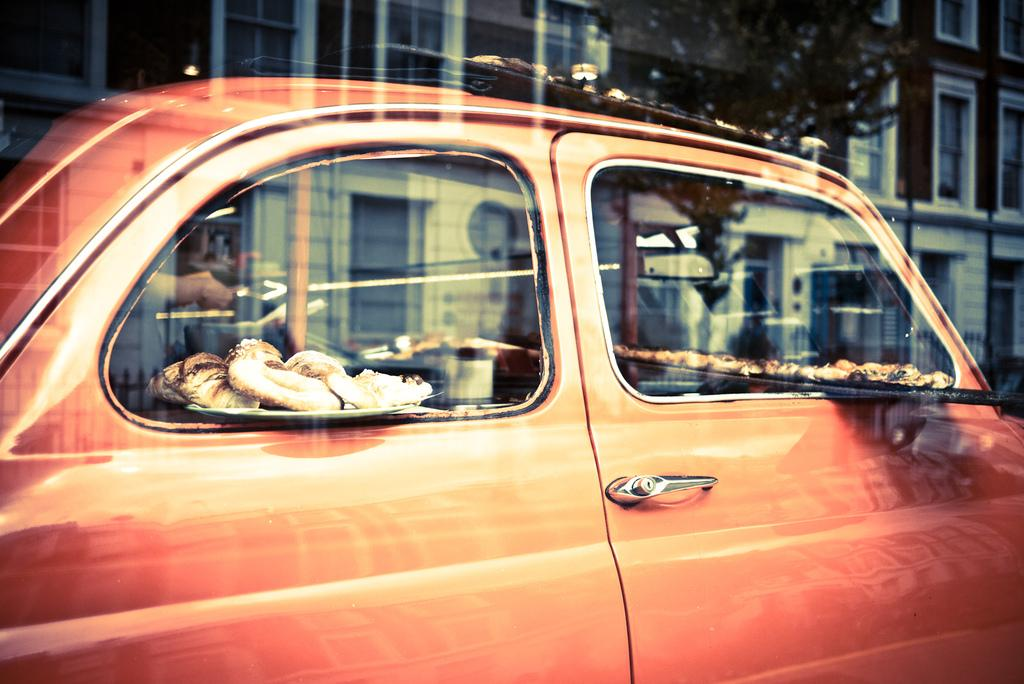What color is the car in the image? The car in the image is orange. What is on the plate can be seen in the image? There is a plate containing eatables in the image. Whose hands are visible in the image? The hands of a person are visible in the image. What can be seen in the distance in the image? There are buildings and a tree in the background of the image. Can you tell me what time the person is wearing on their wrist in the image? There is no watch visible on the person's wrist in the image. What type of sea creature can be seen swimming in the background of the image? There is no sea or sea creature present in the image; it features a tree and buildings in the background. 